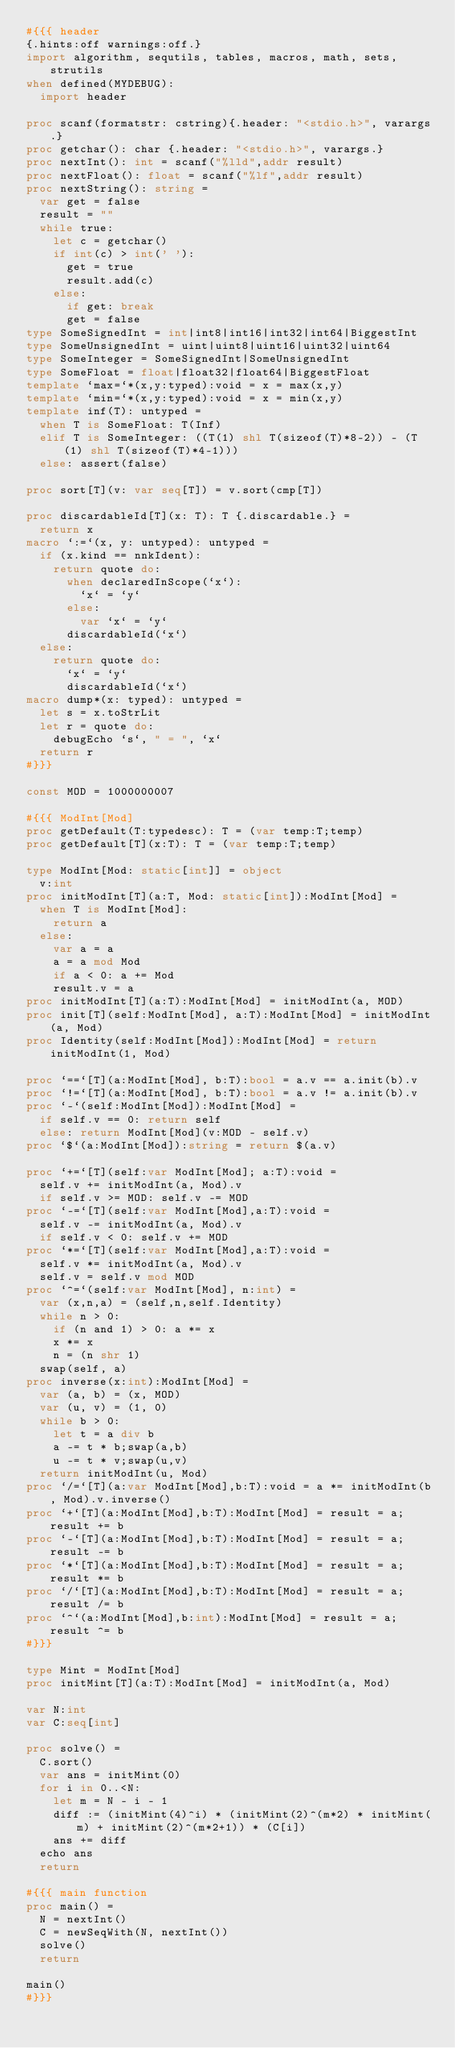Convert code to text. <code><loc_0><loc_0><loc_500><loc_500><_Nim_>#{{{ header
{.hints:off warnings:off.}
import algorithm, sequtils, tables, macros, math, sets, strutils
when defined(MYDEBUG):
  import header

proc scanf(formatstr: cstring){.header: "<stdio.h>", varargs.}
proc getchar(): char {.header: "<stdio.h>", varargs.}
proc nextInt(): int = scanf("%lld",addr result)
proc nextFloat(): float = scanf("%lf",addr result)
proc nextString(): string =
  var get = false
  result = ""
  while true:
    let c = getchar()
    if int(c) > int(' '):
      get = true
      result.add(c)
    else:
      if get: break
      get = false
type SomeSignedInt = int|int8|int16|int32|int64|BiggestInt
type SomeUnsignedInt = uint|uint8|uint16|uint32|uint64
type SomeInteger = SomeSignedInt|SomeUnsignedInt
type SomeFloat = float|float32|float64|BiggestFloat
template `max=`*(x,y:typed):void = x = max(x,y)
template `min=`*(x,y:typed):void = x = min(x,y)
template inf(T): untyped = 
  when T is SomeFloat: T(Inf)
  elif T is SomeInteger: ((T(1) shl T(sizeof(T)*8-2)) - (T(1) shl T(sizeof(T)*4-1)))
  else: assert(false)

proc sort[T](v: var seq[T]) = v.sort(cmp[T])

proc discardableId[T](x: T): T {.discardable.} =
  return x
macro `:=`(x, y: untyped): untyped =
  if (x.kind == nnkIdent):
    return quote do:
      when declaredInScope(`x`):
        `x` = `y`
      else:
        var `x` = `y`
      discardableId(`x`)
  else:
    return quote do:
      `x` = `y`
      discardableId(`x`)
macro dump*(x: typed): untyped =
  let s = x.toStrLit
  let r = quote do:
    debugEcho `s`, " = ", `x`
  return r
#}}}

const MOD = 1000000007

#{{{ ModInt[Mod]
proc getDefault(T:typedesc): T = (var temp:T;temp)
proc getDefault[T](x:T): T = (var temp:T;temp)

type ModInt[Mod: static[int]] = object
  v:int
proc initModInt[T](a:T, Mod: static[int]):ModInt[Mod] =
  when T is ModInt[Mod]:
    return a
  else:
    var a = a
    a = a mod Mod
    if a < 0: a += Mod
    result.v = a
proc initModInt[T](a:T):ModInt[Mod] = initModInt(a, MOD)
proc init[T](self:ModInt[Mod], a:T):ModInt[Mod] = initModInt(a, Mod)
proc Identity(self:ModInt[Mod]):ModInt[Mod] = return initModInt(1, Mod)

proc `==`[T](a:ModInt[Mod], b:T):bool = a.v == a.init(b).v
proc `!=`[T](a:ModInt[Mod], b:T):bool = a.v != a.init(b).v
proc `-`(self:ModInt[Mod]):ModInt[Mod] =
  if self.v == 0: return self
  else: return ModInt[Mod](v:MOD - self.v)
proc `$`(a:ModInt[Mod]):string = return $(a.v)

proc `+=`[T](self:var ModInt[Mod]; a:T):void =
  self.v += initModInt(a, Mod).v
  if self.v >= MOD: self.v -= MOD
proc `-=`[T](self:var ModInt[Mod],a:T):void =
  self.v -= initModInt(a, Mod).v
  if self.v < 0: self.v += MOD
proc `*=`[T](self:var ModInt[Mod],a:T):void =
  self.v *= initModInt(a, Mod).v
  self.v = self.v mod MOD
proc `^=`(self:var ModInt[Mod], n:int) =
  var (x,n,a) = (self,n,self.Identity)
  while n > 0:
    if (n and 1) > 0: a *= x
    x *= x
    n = (n shr 1)
  swap(self, a)
proc inverse(x:int):ModInt[Mod] =
  var (a, b) = (x, MOD)
  var (u, v) = (1, 0)
  while b > 0:
    let t = a div b
    a -= t * b;swap(a,b)
    u -= t * v;swap(u,v)
  return initModInt(u, Mod)
proc `/=`[T](a:var ModInt[Mod],b:T):void = a *= initModInt(b, Mod).v.inverse()
proc `+`[T](a:ModInt[Mod],b:T):ModInt[Mod] = result = a;result += b
proc `-`[T](a:ModInt[Mod],b:T):ModInt[Mod] = result = a;result -= b
proc `*`[T](a:ModInt[Mod],b:T):ModInt[Mod] = result = a;result *= b
proc `/`[T](a:ModInt[Mod],b:T):ModInt[Mod] = result = a; result /= b
proc `^`(a:ModInt[Mod],b:int):ModInt[Mod] = result = a; result ^= b
#}}}

type Mint = ModInt[Mod]
proc initMint[T](a:T):ModInt[Mod] = initModInt(a, Mod)

var N:int
var C:seq[int]

proc solve() =
  C.sort()
  var ans = initMint(0)
  for i in 0..<N:
    let m = N - i - 1
    diff := (initMint(4)^i) * (initMint(2)^(m*2) * initMint(m) + initMint(2)^(m*2+1)) * (C[i])
    ans += diff
  echo ans
  return

#{{{ main function
proc main() =
  N = nextInt()
  C = newSeqWith(N, nextInt())
  solve()
  return

main()
#}}}
</code> 